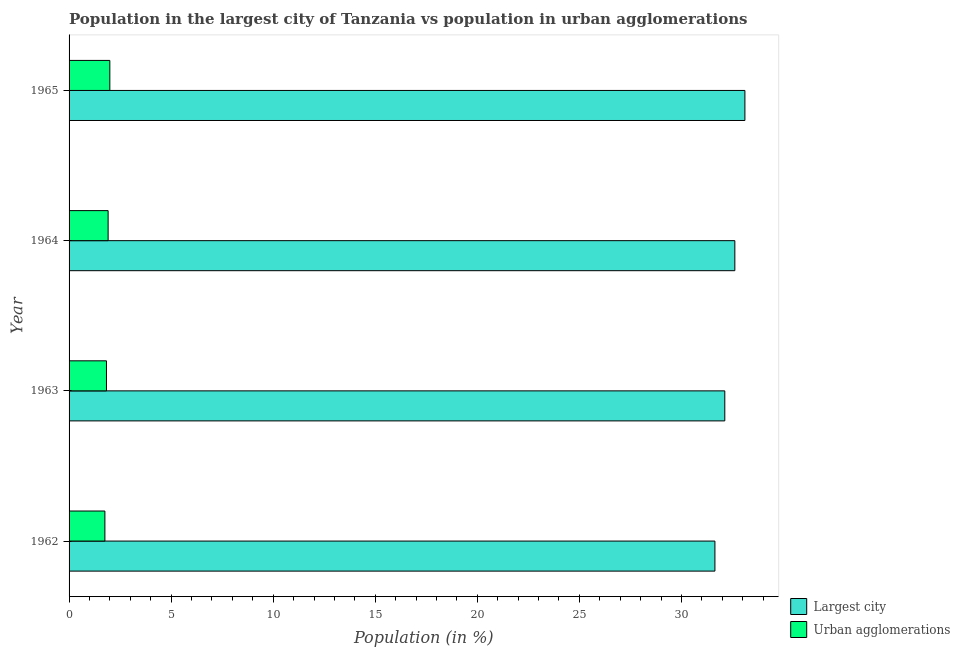How many groups of bars are there?
Keep it short and to the point. 4. Are the number of bars on each tick of the Y-axis equal?
Your response must be concise. Yes. How many bars are there on the 1st tick from the top?
Offer a terse response. 2. How many bars are there on the 2nd tick from the bottom?
Your answer should be compact. 2. In how many cases, is the number of bars for a given year not equal to the number of legend labels?
Offer a terse response. 0. What is the population in the largest city in 1965?
Provide a short and direct response. 33.11. Across all years, what is the maximum population in the largest city?
Provide a succinct answer. 33.11. Across all years, what is the minimum population in the largest city?
Your answer should be very brief. 31.64. In which year was the population in the largest city maximum?
Provide a short and direct response. 1965. In which year was the population in urban agglomerations minimum?
Provide a short and direct response. 1962. What is the total population in urban agglomerations in the graph?
Your response must be concise. 7.5. What is the difference between the population in the largest city in 1964 and that in 1965?
Your answer should be compact. -0.49. What is the difference between the population in urban agglomerations in 1963 and the population in the largest city in 1965?
Give a very brief answer. -31.28. What is the average population in the largest city per year?
Your response must be concise. 32.37. In the year 1962, what is the difference between the population in urban agglomerations and population in the largest city?
Your answer should be compact. -29.88. What is the ratio of the population in the largest city in 1963 to that in 1964?
Give a very brief answer. 0.98. Is the difference between the population in urban agglomerations in 1962 and 1964 greater than the difference between the population in the largest city in 1962 and 1964?
Your answer should be very brief. Yes. What is the difference between the highest and the second highest population in the largest city?
Make the answer very short. 0.49. What is the difference between the highest and the lowest population in urban agglomerations?
Make the answer very short. 0.24. In how many years, is the population in the largest city greater than the average population in the largest city taken over all years?
Give a very brief answer. 2. What does the 1st bar from the top in 1962 represents?
Your answer should be very brief. Urban agglomerations. What does the 1st bar from the bottom in 1963 represents?
Ensure brevity in your answer.  Largest city. How many bars are there?
Provide a succinct answer. 8. Are the values on the major ticks of X-axis written in scientific E-notation?
Make the answer very short. No. Does the graph contain grids?
Your response must be concise. No. Where does the legend appear in the graph?
Provide a succinct answer. Bottom right. How are the legend labels stacked?
Your answer should be very brief. Vertical. What is the title of the graph?
Offer a terse response. Population in the largest city of Tanzania vs population in urban agglomerations. Does "Merchandise exports" appear as one of the legend labels in the graph?
Provide a succinct answer. No. What is the label or title of the X-axis?
Make the answer very short. Population (in %). What is the label or title of the Y-axis?
Provide a short and direct response. Year. What is the Population (in %) of Largest city in 1962?
Ensure brevity in your answer.  31.64. What is the Population (in %) of Urban agglomerations in 1962?
Offer a very short reply. 1.76. What is the Population (in %) of Largest city in 1963?
Make the answer very short. 32.12. What is the Population (in %) in Urban agglomerations in 1963?
Your answer should be compact. 1.83. What is the Population (in %) in Largest city in 1964?
Provide a short and direct response. 32.62. What is the Population (in %) in Urban agglomerations in 1964?
Provide a succinct answer. 1.91. What is the Population (in %) in Largest city in 1965?
Give a very brief answer. 33.11. What is the Population (in %) in Urban agglomerations in 1965?
Provide a succinct answer. 2. Across all years, what is the maximum Population (in %) of Largest city?
Make the answer very short. 33.11. Across all years, what is the maximum Population (in %) in Urban agglomerations?
Your answer should be very brief. 2. Across all years, what is the minimum Population (in %) in Largest city?
Provide a succinct answer. 31.64. Across all years, what is the minimum Population (in %) in Urban agglomerations?
Provide a succinct answer. 1.76. What is the total Population (in %) of Largest city in the graph?
Provide a succinct answer. 129.49. What is the total Population (in %) in Urban agglomerations in the graph?
Offer a very short reply. 7.5. What is the difference between the Population (in %) of Largest city in 1962 and that in 1963?
Offer a very short reply. -0.48. What is the difference between the Population (in %) of Urban agglomerations in 1962 and that in 1963?
Your answer should be compact. -0.08. What is the difference between the Population (in %) in Largest city in 1962 and that in 1964?
Provide a succinct answer. -0.98. What is the difference between the Population (in %) in Urban agglomerations in 1962 and that in 1964?
Provide a short and direct response. -0.16. What is the difference between the Population (in %) in Largest city in 1962 and that in 1965?
Your answer should be very brief. -1.47. What is the difference between the Population (in %) in Urban agglomerations in 1962 and that in 1965?
Offer a very short reply. -0.24. What is the difference between the Population (in %) in Largest city in 1963 and that in 1964?
Give a very brief answer. -0.49. What is the difference between the Population (in %) in Urban agglomerations in 1963 and that in 1964?
Offer a very short reply. -0.08. What is the difference between the Population (in %) of Largest city in 1963 and that in 1965?
Make the answer very short. -0.99. What is the difference between the Population (in %) in Urban agglomerations in 1963 and that in 1965?
Offer a very short reply. -0.16. What is the difference between the Population (in %) in Largest city in 1964 and that in 1965?
Ensure brevity in your answer.  -0.49. What is the difference between the Population (in %) of Urban agglomerations in 1964 and that in 1965?
Your response must be concise. -0.08. What is the difference between the Population (in %) in Largest city in 1962 and the Population (in %) in Urban agglomerations in 1963?
Offer a very short reply. 29.81. What is the difference between the Population (in %) in Largest city in 1962 and the Population (in %) in Urban agglomerations in 1964?
Offer a terse response. 29.73. What is the difference between the Population (in %) of Largest city in 1962 and the Population (in %) of Urban agglomerations in 1965?
Your answer should be compact. 29.64. What is the difference between the Population (in %) of Largest city in 1963 and the Population (in %) of Urban agglomerations in 1964?
Keep it short and to the point. 30.21. What is the difference between the Population (in %) in Largest city in 1963 and the Population (in %) in Urban agglomerations in 1965?
Your answer should be compact. 30.13. What is the difference between the Population (in %) in Largest city in 1964 and the Population (in %) in Urban agglomerations in 1965?
Provide a succinct answer. 30.62. What is the average Population (in %) of Largest city per year?
Provide a succinct answer. 32.37. What is the average Population (in %) of Urban agglomerations per year?
Make the answer very short. 1.87. In the year 1962, what is the difference between the Population (in %) in Largest city and Population (in %) in Urban agglomerations?
Ensure brevity in your answer.  29.88. In the year 1963, what is the difference between the Population (in %) in Largest city and Population (in %) in Urban agglomerations?
Provide a succinct answer. 30.29. In the year 1964, what is the difference between the Population (in %) of Largest city and Population (in %) of Urban agglomerations?
Provide a short and direct response. 30.7. In the year 1965, what is the difference between the Population (in %) of Largest city and Population (in %) of Urban agglomerations?
Give a very brief answer. 31.11. What is the ratio of the Population (in %) of Largest city in 1962 to that in 1963?
Offer a terse response. 0.98. What is the ratio of the Population (in %) of Urban agglomerations in 1962 to that in 1963?
Make the answer very short. 0.96. What is the ratio of the Population (in %) of Largest city in 1962 to that in 1964?
Give a very brief answer. 0.97. What is the ratio of the Population (in %) of Urban agglomerations in 1962 to that in 1964?
Provide a succinct answer. 0.92. What is the ratio of the Population (in %) in Largest city in 1962 to that in 1965?
Provide a succinct answer. 0.96. What is the ratio of the Population (in %) in Urban agglomerations in 1962 to that in 1965?
Provide a succinct answer. 0.88. What is the ratio of the Population (in %) of Largest city in 1963 to that in 1964?
Ensure brevity in your answer.  0.98. What is the ratio of the Population (in %) of Urban agglomerations in 1963 to that in 1964?
Provide a succinct answer. 0.96. What is the ratio of the Population (in %) in Largest city in 1963 to that in 1965?
Keep it short and to the point. 0.97. What is the ratio of the Population (in %) in Urban agglomerations in 1963 to that in 1965?
Offer a very short reply. 0.92. What is the ratio of the Population (in %) in Largest city in 1964 to that in 1965?
Your answer should be compact. 0.99. What is the ratio of the Population (in %) in Urban agglomerations in 1964 to that in 1965?
Provide a succinct answer. 0.96. What is the difference between the highest and the second highest Population (in %) of Largest city?
Offer a very short reply. 0.49. What is the difference between the highest and the second highest Population (in %) of Urban agglomerations?
Offer a terse response. 0.08. What is the difference between the highest and the lowest Population (in %) in Largest city?
Your response must be concise. 1.47. What is the difference between the highest and the lowest Population (in %) in Urban agglomerations?
Provide a succinct answer. 0.24. 